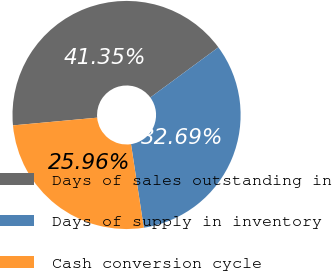Convert chart. <chart><loc_0><loc_0><loc_500><loc_500><pie_chart><fcel>Days of sales outstanding in<fcel>Days of supply in inventory<fcel>Cash conversion cycle<nl><fcel>41.35%<fcel>32.69%<fcel>25.96%<nl></chart> 